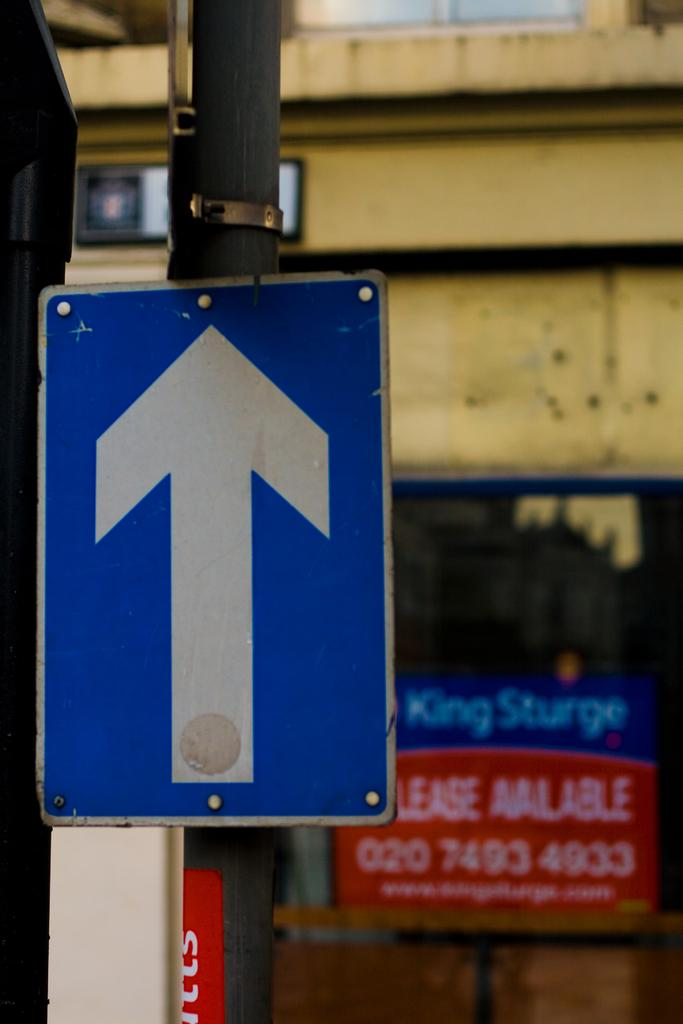What is located in the foreground of the image? There is a sign board in the foreground of the image. How is the sign board supported? The sign board is attached to a pole. What can be seen in the background of the image? There is a wall, glass, and a board in the background of the image. How many cars are parked on the foot in the image? There are no cars or feet present in the image. 